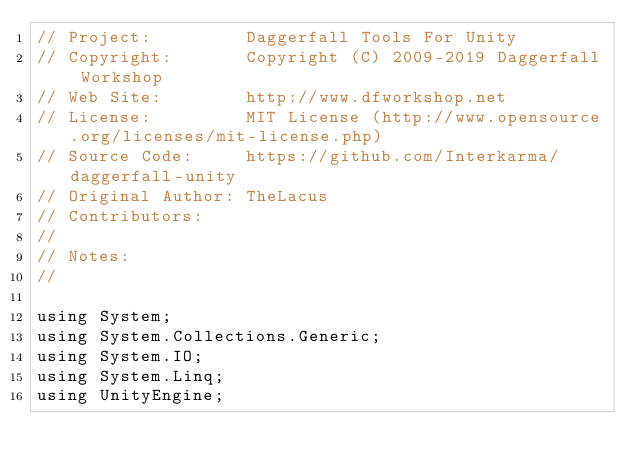<code> <loc_0><loc_0><loc_500><loc_500><_C#_>// Project:         Daggerfall Tools For Unity
// Copyright:       Copyright (C) 2009-2019 Daggerfall Workshop
// Web Site:        http://www.dfworkshop.net
// License:         MIT License (http://www.opensource.org/licenses/mit-license.php)
// Source Code:     https://github.com/Interkarma/daggerfall-unity
// Original Author: TheLacus
// Contributors:
// 
// Notes:
//

using System;
using System.Collections.Generic;
using System.IO;
using System.Linq;
using UnityEngine;</code> 